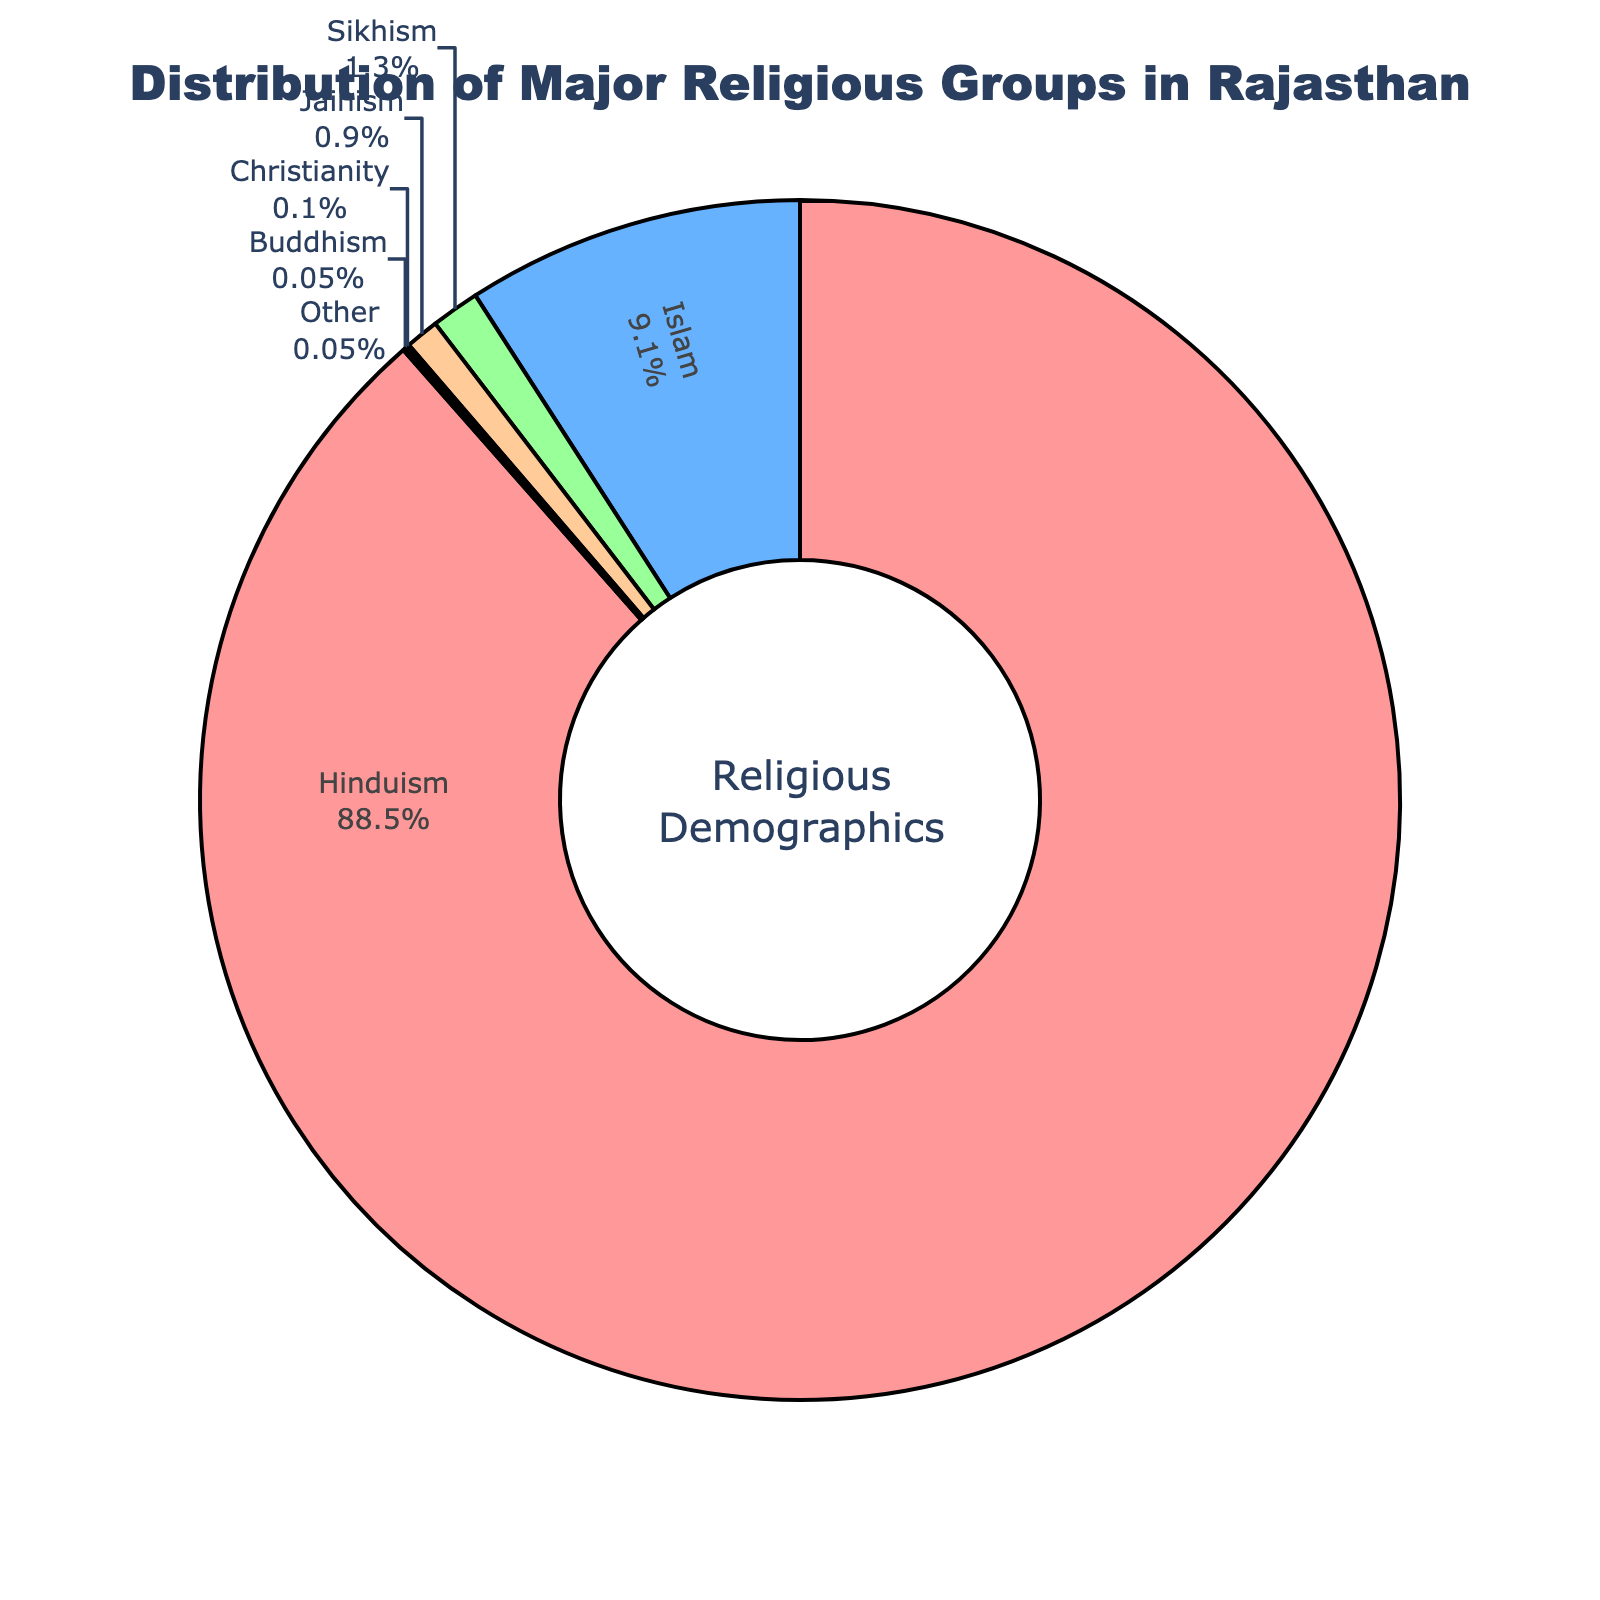What is the percentage of people practicing Jainism in Rajasthan? The figure shows a pie chart of the distribution of major religious groups in Rajasthan. By looking at the segment corresponding to Jainism, we can see that it represents 0.9% of the population.
Answer: 0.9% Which two religious groups combined make up exactly 0.1% of the population? By examining the segments in the pie chart, we can identify the smallest slices labeled Buddhism and Other. The percentages are 0.05% each. Adding 0.05% + 0.05% equals 0.1%.
Answer: Buddhism and Other What is the difference in percentage points between Hinduism and Islam? Referring to the pie chart, Hinduism accounts for 88.5%, while Islam accounts for 9.1%. To find the difference, subtract 9.1 from 88.5, which equals 79.4.
Answer: 79.4 What percentage of the population does not practice Hinduism? The figure has Hinduism at 88.5%. To find the percentage of people not practicing Hinduism, subtract 88.5 from 100, which is 11.5%.
Answer: 11.5% What is the smallest religious group in Rajasthan based on the pie chart? The smallest religious group in the pie chart has segments showing the least percentages labeled as both Christianity and Buddhism, each making up 0.05% of the population.
Answer: Christianity and Buddhism What is the total percentage for Islam and Sikhism together? Adding the percentages of Islam (9.1%) and Sikhism (1.3%) from the pie chart, we get 9.1 + 1.3 = 10.4%.
Answer: 10.4% How many religious groups in Rajasthan have a percentage lower than 1%? By examining the pie chart, we can see that the segments for Jainism (0.9%), Christianity (0.1%), Buddhism (0.05%), and Other (0.05%) are all below 1%. Counting these groups gives us a total of 4 groups.
Answer: 4 Which religious group is represented by the red color in the pie chart? Observing the pie chart, the segment colored red corresponds to Hinduism.
Answer: Hinduism 